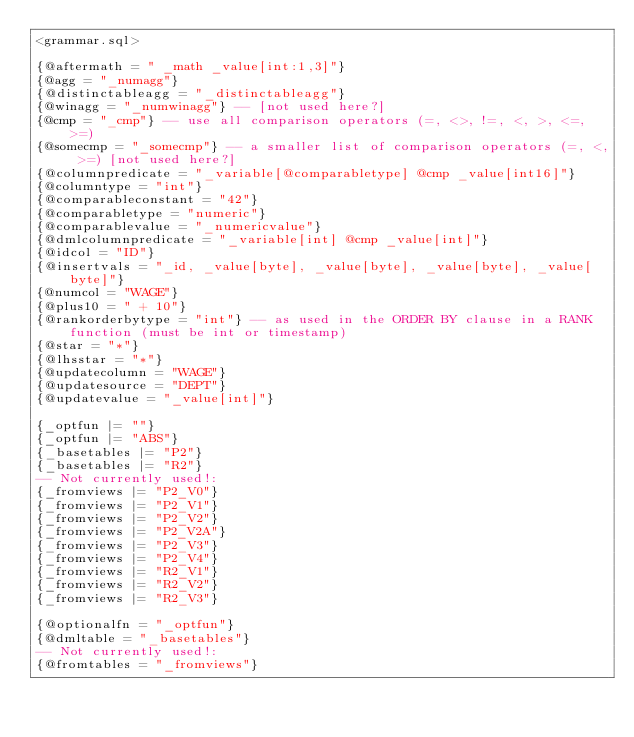Convert code to text. <code><loc_0><loc_0><loc_500><loc_500><_SQL_><grammar.sql>

{@aftermath = " _math _value[int:1,3]"}
{@agg = "_numagg"}
{@distinctableagg = "_distinctableagg"}
{@winagg = "_numwinagg"} -- [not used here?]
{@cmp = "_cmp"} -- use all comparison operators (=, <>, !=, <, >, <=, >=)
{@somecmp = "_somecmp"} -- a smaller list of comparison operators (=, <, >=) [not used here?]
{@columnpredicate = "_variable[@comparabletype] @cmp _value[int16]"}
{@columntype = "int"}
{@comparableconstant = "42"}
{@comparabletype = "numeric"}
{@comparablevalue = "_numericvalue"}
{@dmlcolumnpredicate = "_variable[int] @cmp _value[int]"}
{@idcol = "ID"}
{@insertvals = "_id, _value[byte], _value[byte], _value[byte], _value[byte]"}
{@numcol = "WAGE"}
{@plus10 = " + 10"}
{@rankorderbytype = "int"} -- as used in the ORDER BY clause in a RANK function (must be int or timestamp)
{@star = "*"}
{@lhsstar = "*"}
{@updatecolumn = "WAGE"}
{@updatesource = "DEPT"}
{@updatevalue = "_value[int]"}

{_optfun |= ""}
{_optfun |= "ABS"}
{_basetables |= "P2"}
{_basetables |= "R2"}
-- Not currently used!:
{_fromviews |= "P2_V0"}
{_fromviews |= "P2_V1"}
{_fromviews |= "P2_V2"}
{_fromviews |= "P2_V2A"}
{_fromviews |= "P2_V3"}
{_fromviews |= "P2_V4"}
{_fromviews |= "R2_V1"}
{_fromviews |= "R2_V2"}
{_fromviews |= "R2_V3"}

{@optionalfn = "_optfun"}
{@dmltable = "_basetables"}
-- Not currently used!:
{@fromtables = "_fromviews"}
</code> 